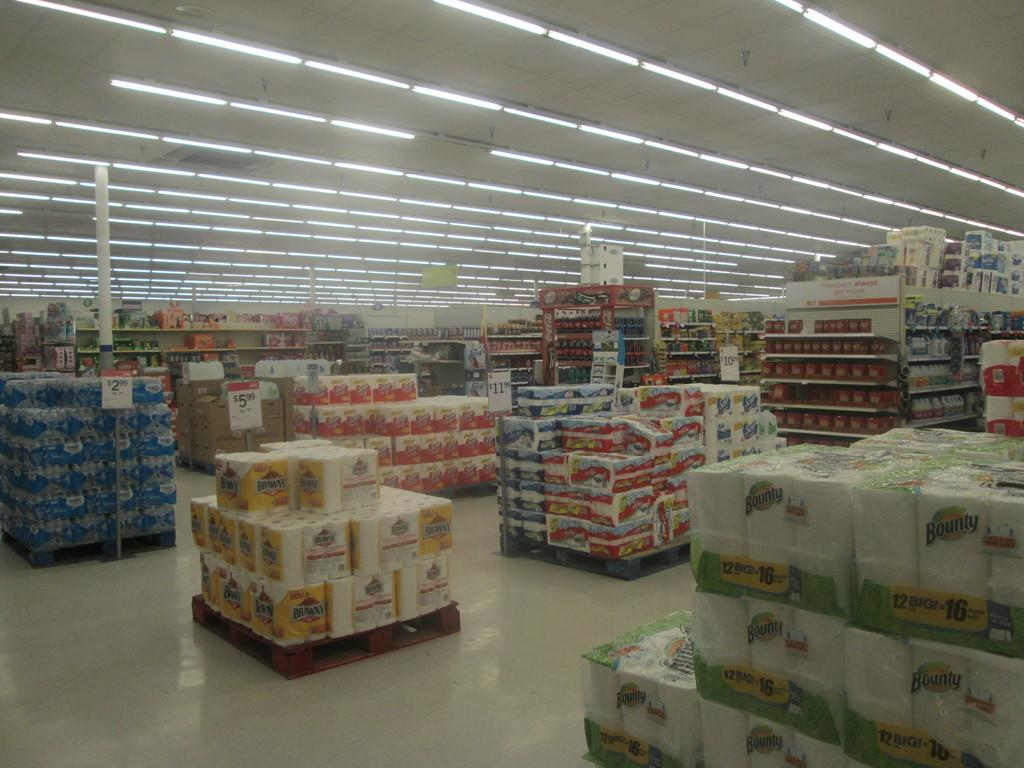Provide a one-sentence caption for the provided image. Packages of products including Brawny and Bounty paper towels are stack in a store for sale. 